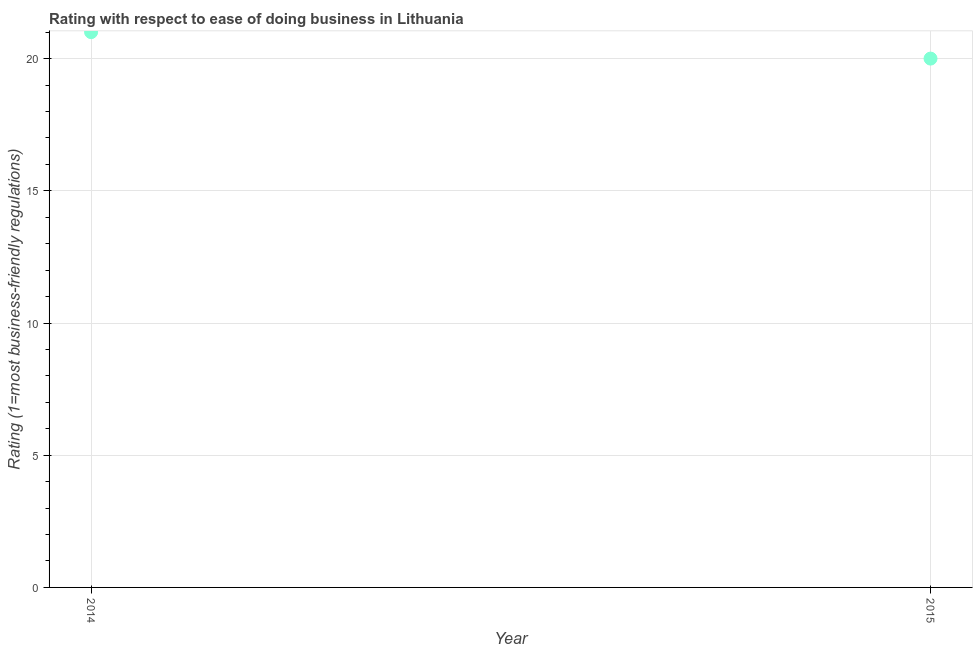What is the ease of doing business index in 2015?
Provide a short and direct response. 20. Across all years, what is the maximum ease of doing business index?
Offer a terse response. 21. Across all years, what is the minimum ease of doing business index?
Ensure brevity in your answer.  20. In which year was the ease of doing business index minimum?
Your response must be concise. 2015. What is the sum of the ease of doing business index?
Your answer should be very brief. 41. What is the difference between the ease of doing business index in 2014 and 2015?
Offer a very short reply. 1. What is the average ease of doing business index per year?
Keep it short and to the point. 20.5. In how many years, is the ease of doing business index greater than the average ease of doing business index taken over all years?
Your answer should be compact. 1. Does the ease of doing business index monotonically increase over the years?
Provide a short and direct response. No. What is the difference between two consecutive major ticks on the Y-axis?
Make the answer very short. 5. Are the values on the major ticks of Y-axis written in scientific E-notation?
Keep it short and to the point. No. Does the graph contain any zero values?
Your answer should be very brief. No. What is the title of the graph?
Give a very brief answer. Rating with respect to ease of doing business in Lithuania. What is the label or title of the Y-axis?
Make the answer very short. Rating (1=most business-friendly regulations). 